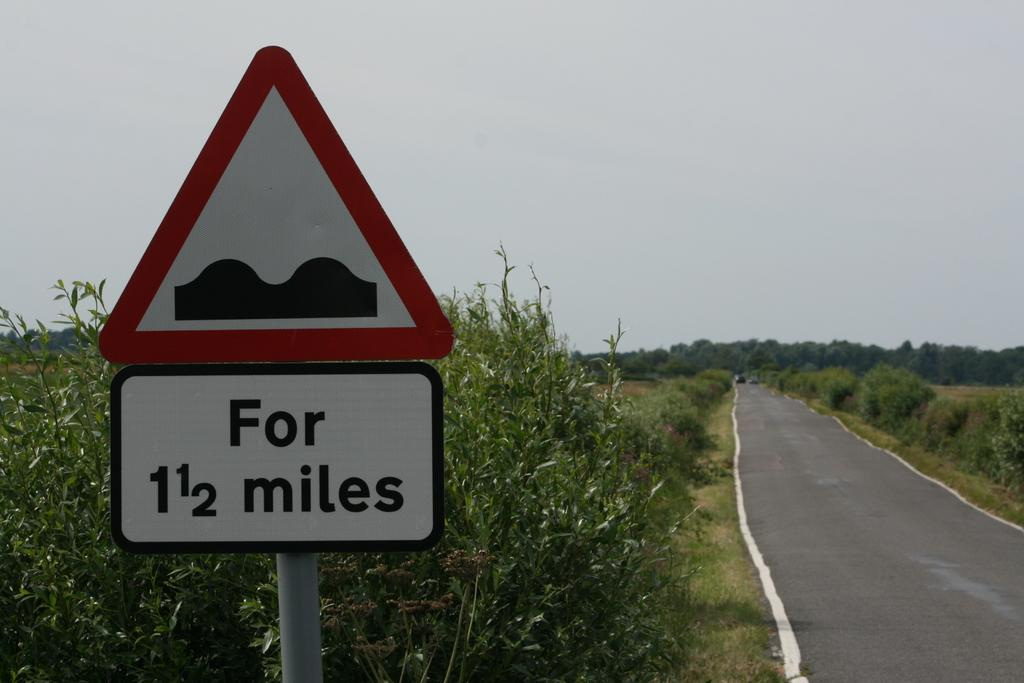<image>
Offer a succinct explanation of the picture presented. White sign which says "For 1 1/2 miles" on it. 